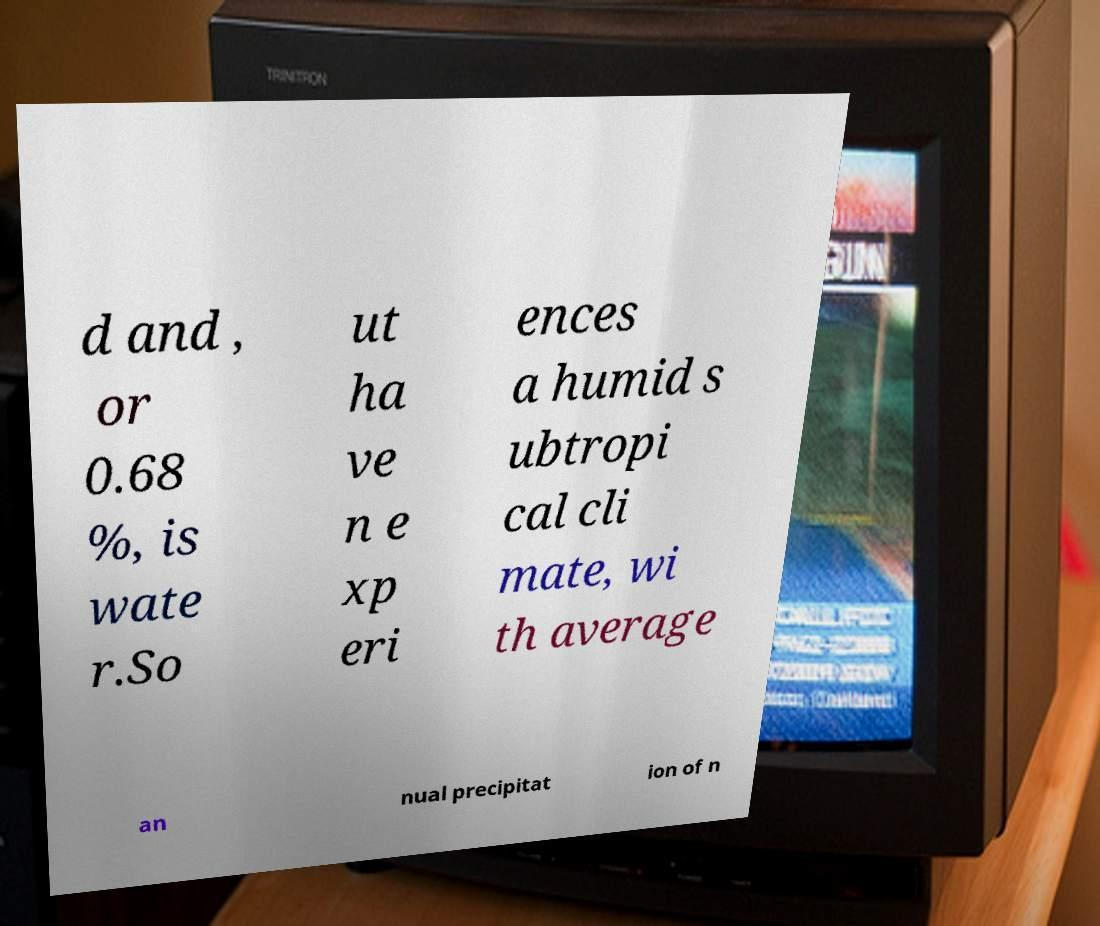For documentation purposes, I need the text within this image transcribed. Could you provide that? d and , or 0.68 %, is wate r.So ut ha ve n e xp eri ences a humid s ubtropi cal cli mate, wi th average an nual precipitat ion of n 